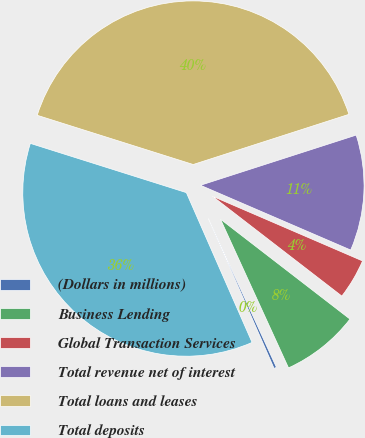Convert chart to OTSL. <chart><loc_0><loc_0><loc_500><loc_500><pie_chart><fcel>(Dollars in millions)<fcel>Business Lending<fcel>Global Transaction Services<fcel>Total revenue net of interest<fcel>Total loans and leases<fcel>Total deposits<nl><fcel>0.25%<fcel>7.71%<fcel>3.98%<fcel>11.44%<fcel>40.17%<fcel>36.44%<nl></chart> 